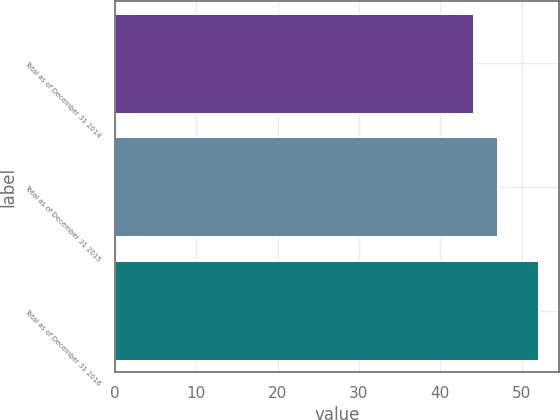Convert chart to OTSL. <chart><loc_0><loc_0><loc_500><loc_500><bar_chart><fcel>Total as of December 31 2014<fcel>Total as of December 31 2015<fcel>Total as of December 31 2016<nl><fcel>44<fcel>47<fcel>52<nl></chart> 